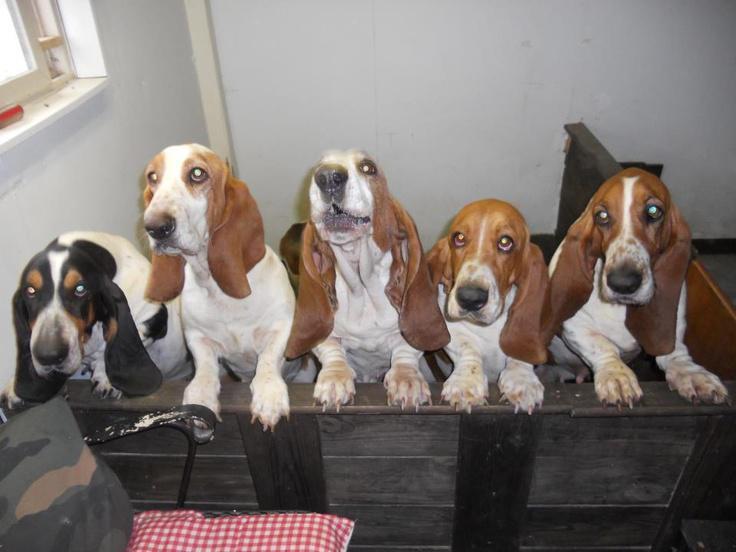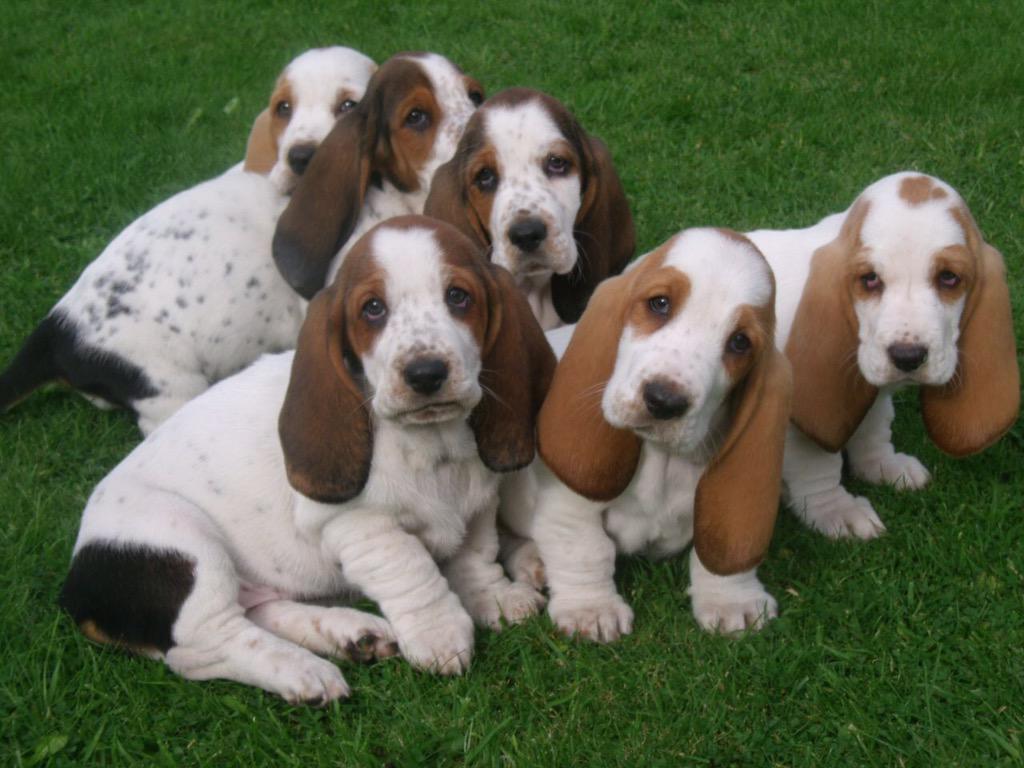The first image is the image on the left, the second image is the image on the right. Given the left and right images, does the statement "In one of the pictures a dog is standing on its hind legs." hold true? Answer yes or no. No. The first image is the image on the left, the second image is the image on the right. Assess this claim about the two images: "There are more than three dogs on the left, and one dog on the right.". Correct or not? Answer yes or no. No. 